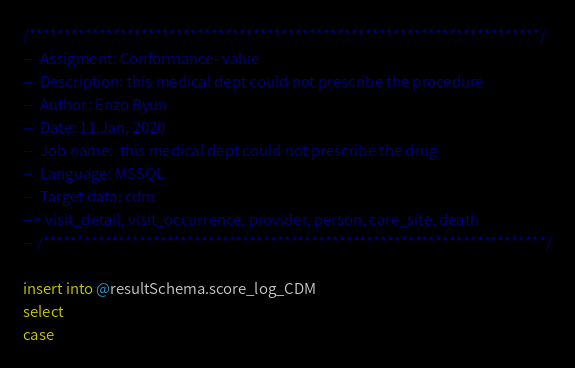Convert code to text. <code><loc_0><loc_0><loc_500><loc_500><_SQL_>/*************************************************************************/
--  Assigment: Conformance- value
--  Description: this medical dept could not prescribe the procedure
--  Author: Enzo Byun
--  Date: 11.Jan, 2020
--  Job name:  this medical dept could not prescribe the drug
--  Language: MSSQL
--  Target data: cdm
--> visit_detail, visit_occurrence, provider, person, care_site, death
-- /*************************************************************************/

insert into @resultSchema.score_log_CDM
select
case</code> 